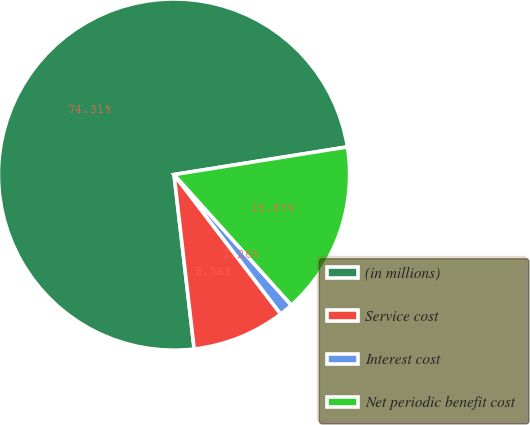Convert chart. <chart><loc_0><loc_0><loc_500><loc_500><pie_chart><fcel>(in millions)<fcel>Service cost<fcel>Interest cost<fcel>Net periodic benefit cost<nl><fcel>74.31%<fcel>8.56%<fcel>1.26%<fcel>15.87%<nl></chart> 